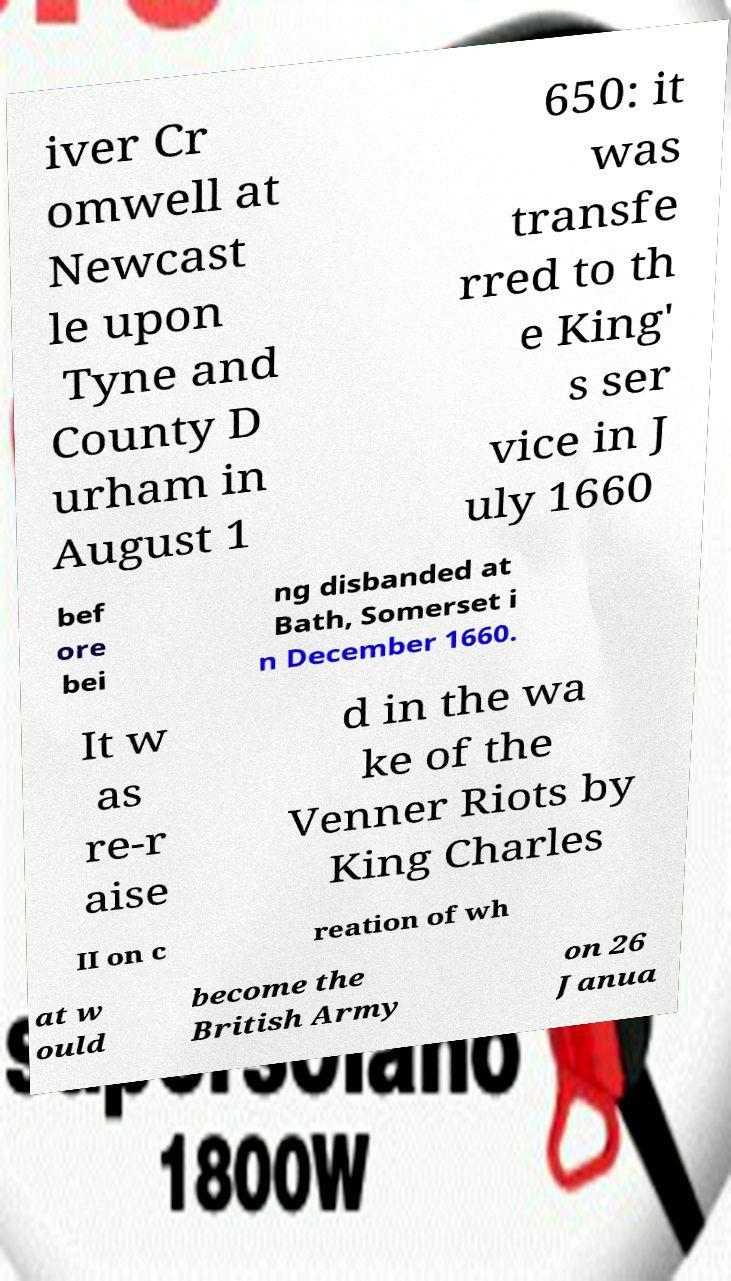What messages or text are displayed in this image? I need them in a readable, typed format. iver Cr omwell at Newcast le upon Tyne and County D urham in August 1 650: it was transfe rred to th e King' s ser vice in J uly 1660 bef ore bei ng disbanded at Bath, Somerset i n December 1660. It w as re-r aise d in the wa ke of the Venner Riots by King Charles II on c reation of wh at w ould become the British Army on 26 Janua 